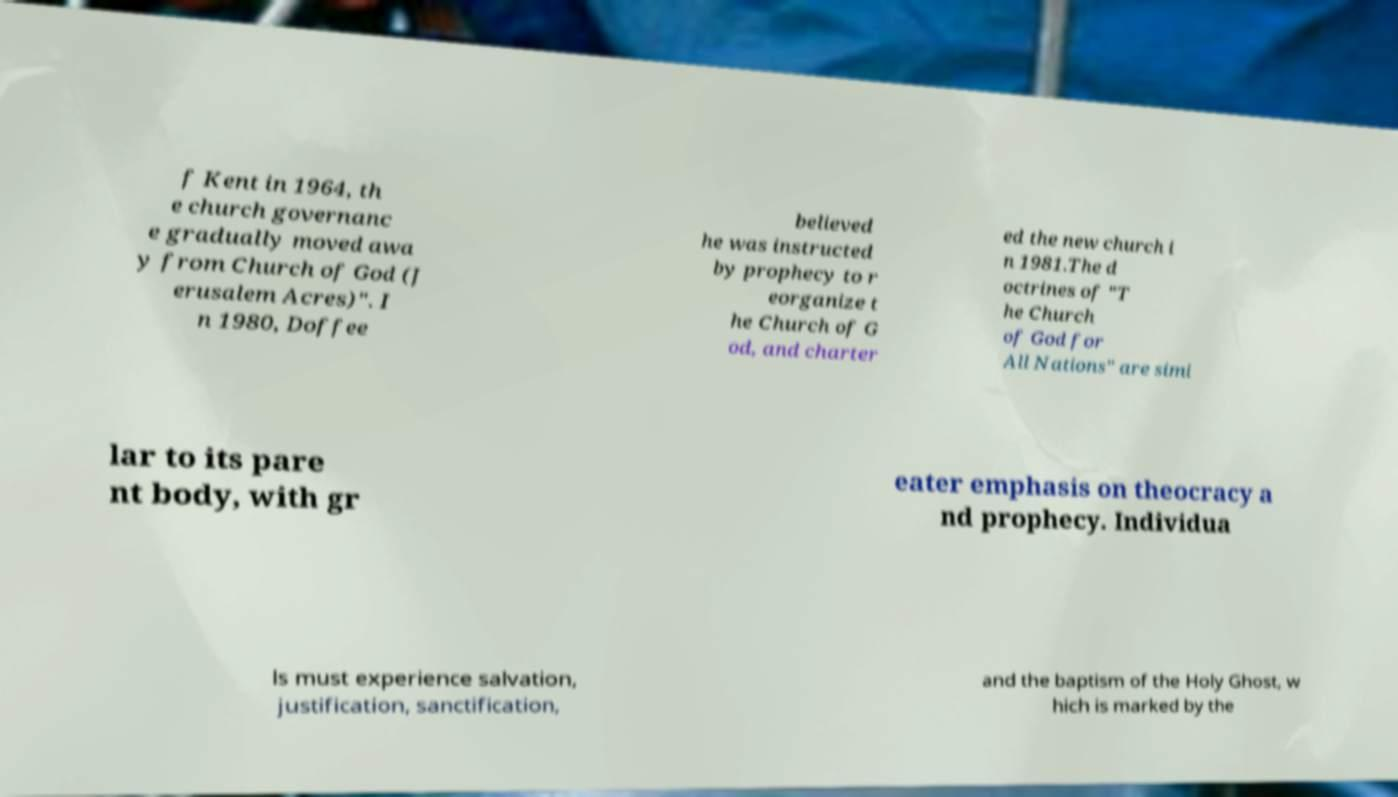There's text embedded in this image that I need extracted. Can you transcribe it verbatim? f Kent in 1964, th e church governanc e gradually moved awa y from Church of God (J erusalem Acres)". I n 1980, Doffee believed he was instructed by prophecy to r eorganize t he Church of G od, and charter ed the new church i n 1981.The d octrines of "T he Church of God for All Nations" are simi lar to its pare nt body, with gr eater emphasis on theocracy a nd prophecy. Individua ls must experience salvation, justification, sanctification, and the baptism of the Holy Ghost, w hich is marked by the 